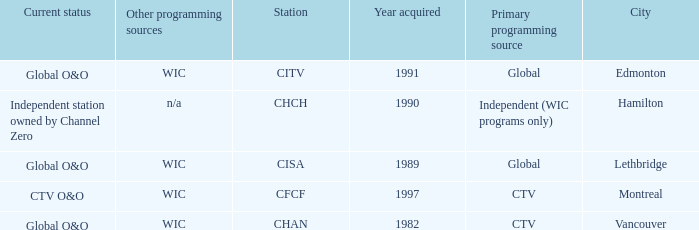How many is the minimum for citv 1991.0. 